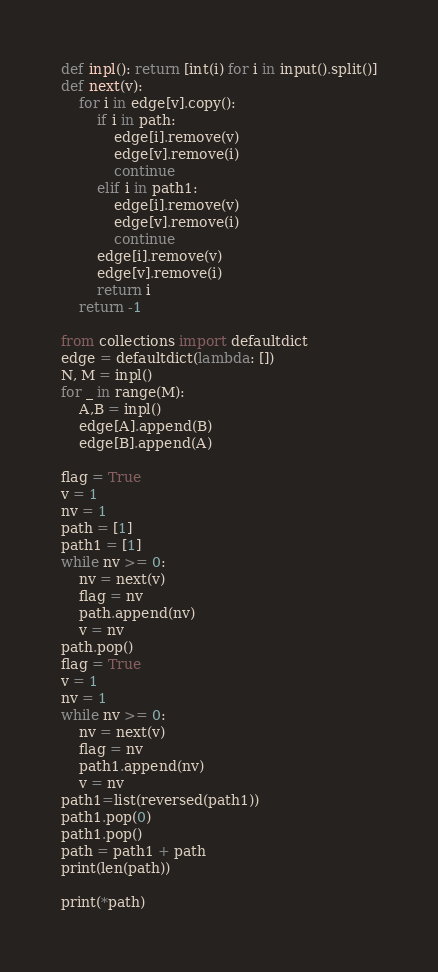Convert code to text. <code><loc_0><loc_0><loc_500><loc_500><_Python_>def inpl(): return [int(i) for i in input().split()]
def next(v):
    for i in edge[v].copy():
        if i in path:
            edge[i].remove(v)
            edge[v].remove(i)
            continue
        elif i in path1:
            edge[i].remove(v)
            edge[v].remove(i)
            continue
        edge[i].remove(v)
        edge[v].remove(i)
        return i
    return -1

from collections import defaultdict
edge = defaultdict(lambda: [])
N, M = inpl()
for _ in range(M):
    A,B = inpl()
    edge[A].append(B)
    edge[B].append(A)

flag = True
v = 1
nv = 1
path = [1]
path1 = [1]
while nv >= 0:
    nv = next(v)
    flag = nv
    path.append(nv)
    v = nv
path.pop()
flag = True
v = 1
nv = 1
while nv >= 0:
    nv = next(v)
    flag = nv
    path1.append(nv)
    v = nv
path1=list(reversed(path1))
path1.pop(0)
path1.pop()
path = path1 + path
print(len(path))

print(*path)</code> 